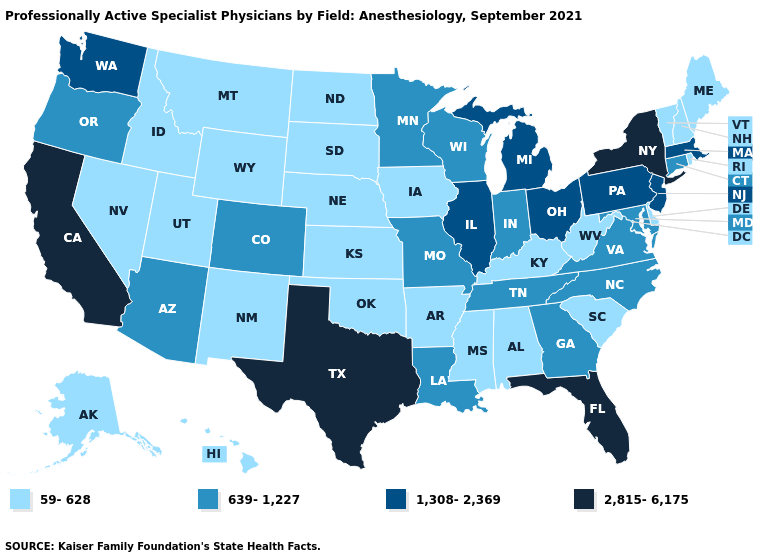Which states have the highest value in the USA?
Quick response, please. California, Florida, New York, Texas. What is the value of Hawaii?
Be succinct. 59-628. What is the value of Hawaii?
Give a very brief answer. 59-628. Does Mississippi have the highest value in the USA?
Keep it brief. No. Name the states that have a value in the range 1,308-2,369?
Concise answer only. Illinois, Massachusetts, Michigan, New Jersey, Ohio, Pennsylvania, Washington. Which states have the lowest value in the USA?
Give a very brief answer. Alabama, Alaska, Arkansas, Delaware, Hawaii, Idaho, Iowa, Kansas, Kentucky, Maine, Mississippi, Montana, Nebraska, Nevada, New Hampshire, New Mexico, North Dakota, Oklahoma, Rhode Island, South Carolina, South Dakota, Utah, Vermont, West Virginia, Wyoming. What is the highest value in states that border Washington?
Quick response, please. 639-1,227. What is the highest value in states that border Tennessee?
Quick response, please. 639-1,227. Is the legend a continuous bar?
Write a very short answer. No. How many symbols are there in the legend?
Keep it brief. 4. What is the value of Virginia?
Write a very short answer. 639-1,227. What is the value of West Virginia?
Concise answer only. 59-628. What is the value of Indiana?
Write a very short answer. 639-1,227. Name the states that have a value in the range 2,815-6,175?
Keep it brief. California, Florida, New York, Texas. Which states have the lowest value in the USA?
Be succinct. Alabama, Alaska, Arkansas, Delaware, Hawaii, Idaho, Iowa, Kansas, Kentucky, Maine, Mississippi, Montana, Nebraska, Nevada, New Hampshire, New Mexico, North Dakota, Oklahoma, Rhode Island, South Carolina, South Dakota, Utah, Vermont, West Virginia, Wyoming. 